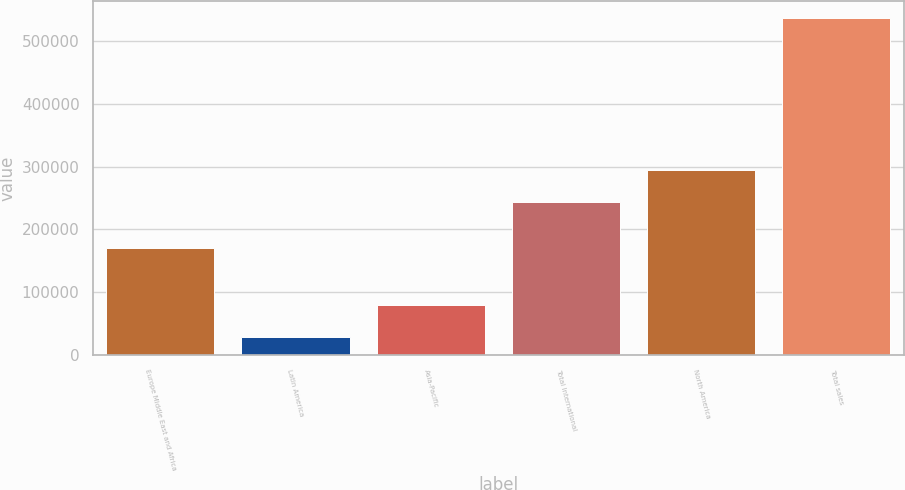Convert chart to OTSL. <chart><loc_0><loc_0><loc_500><loc_500><bar_chart><fcel>Europe Middle East and Africa<fcel>Latin America<fcel>Asia-Pacific<fcel>Total International<fcel>North America<fcel>Total sales<nl><fcel>170544<fcel>29406<fcel>80105.1<fcel>243854<fcel>294553<fcel>536397<nl></chart> 